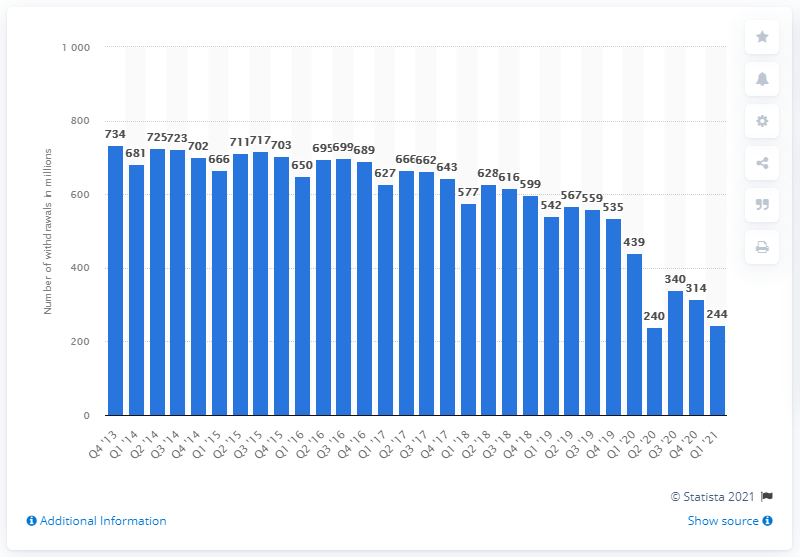Identify some key points in this picture. In the first quarter of 2021, there were 244 cash machine withdrawals. In the fourth quarter of 2013, a total of 734 cash machine withdrawals were recorded in the UK. 